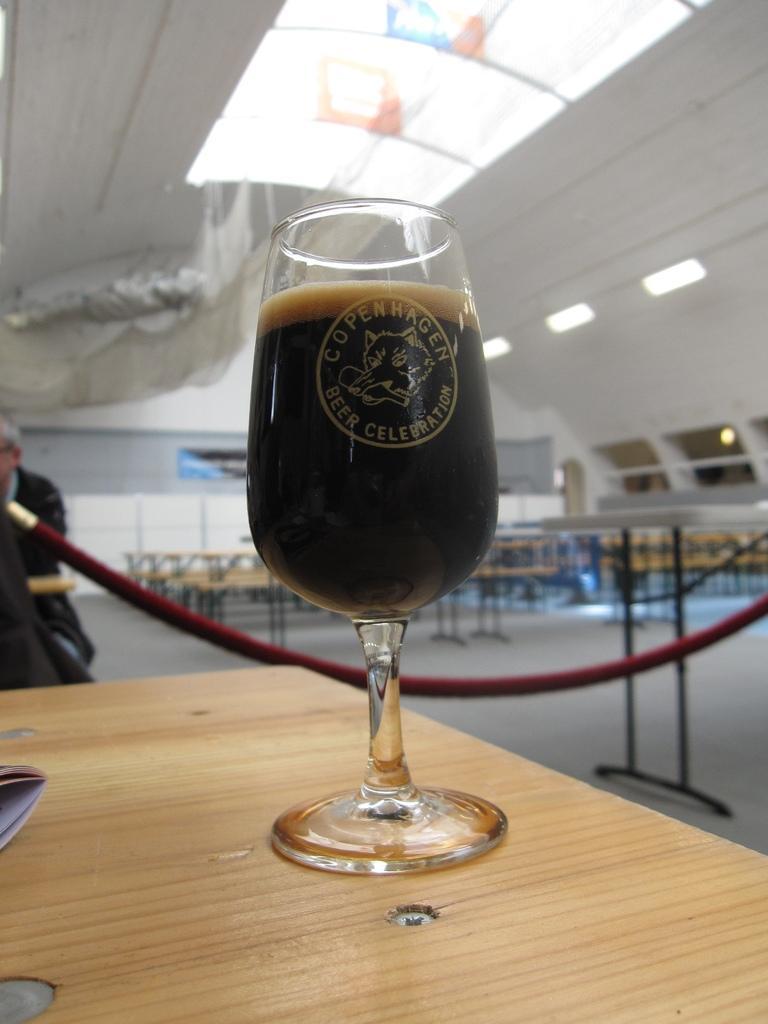Please provide a concise description of this image. Here we can see a glass of beer present on the table and behind and that we can see tables present and at the left side we can see a person and at the top we can see lights 